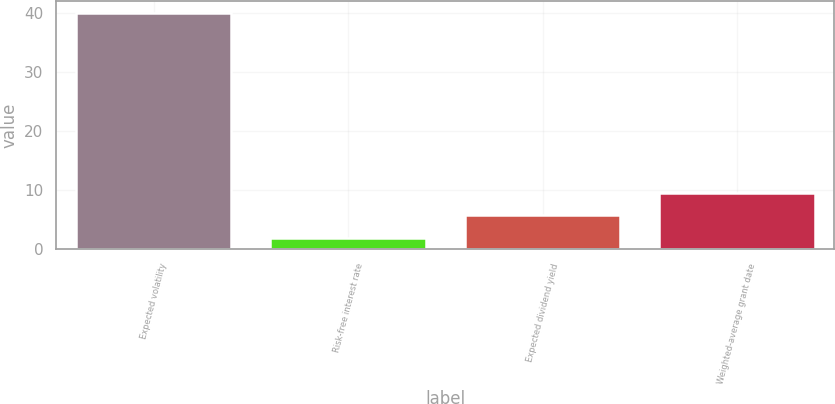Convert chart. <chart><loc_0><loc_0><loc_500><loc_500><bar_chart><fcel>Expected volatility<fcel>Risk-free interest rate<fcel>Expected dividend yield<fcel>Weighted-average grant date<nl><fcel>40<fcel>1.9<fcel>5.71<fcel>9.52<nl></chart> 